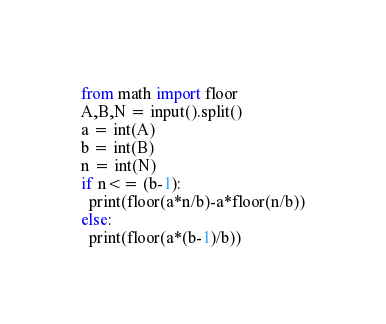<code> <loc_0><loc_0><loc_500><loc_500><_Python_>from math import floor
A,B,N = input().split()
a = int(A)
b = int(B)
n = int(N)
if n<= (b-1):
  print(floor(a*n/b)-a*floor(n/b))
else:
  print(floor(a*(b-1)/b))</code> 